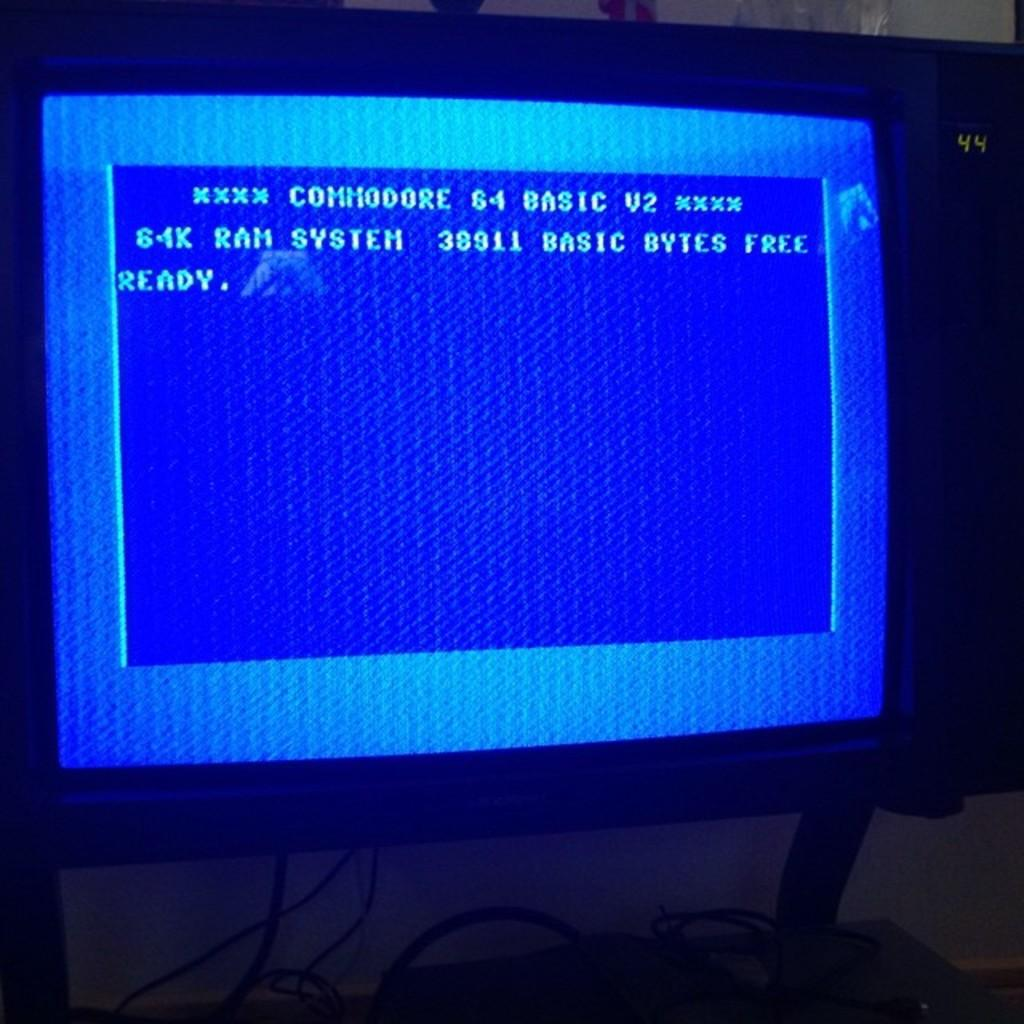Provide a one-sentence caption for the provided image. A monitor displaying the "ready" screen of a Commodore 64 computer. 